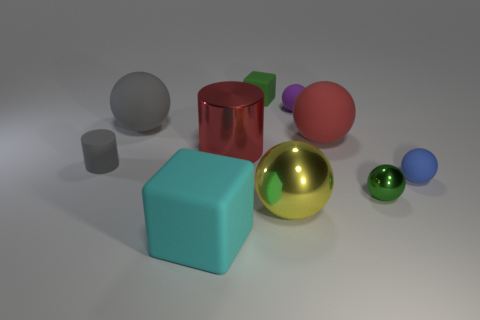There is a big thing that is the same color as the big cylinder; what shape is it?
Provide a short and direct response. Sphere. How many other objects are the same size as the green matte object?
Your response must be concise. 4. The blue thing has what size?
Provide a succinct answer. Small. Is the large gray object made of the same material as the block behind the big cyan rubber object?
Your answer should be compact. Yes. Is there a yellow object that has the same shape as the red rubber object?
Make the answer very short. Yes. There is a gray sphere that is the same size as the cyan cube; what is it made of?
Ensure brevity in your answer.  Rubber. What is the size of the green object that is on the right side of the tiny purple ball?
Offer a terse response. Small. Is the size of the rubber thing in front of the blue matte object the same as the rubber cube on the right side of the large block?
Provide a succinct answer. No. What number of big red cylinders have the same material as the tiny blue ball?
Offer a very short reply. 0. The tiny matte block is what color?
Your answer should be very brief. Green. 